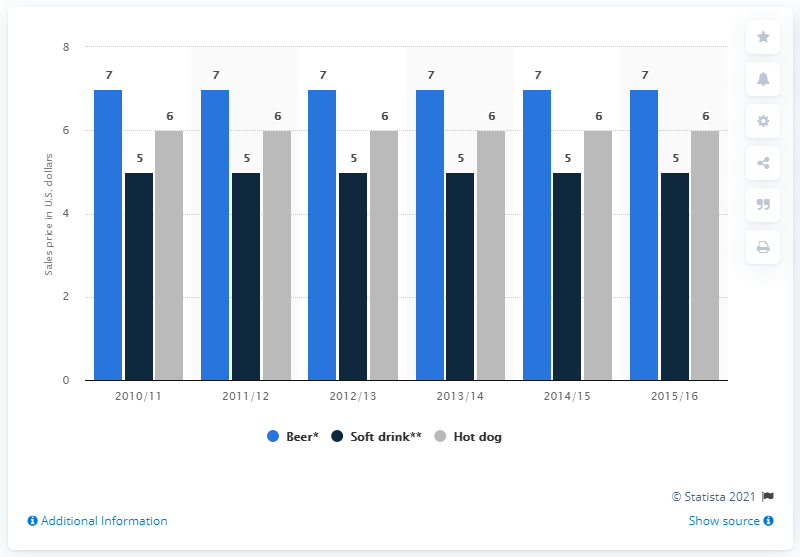Mention a couple of crucial points in this snapshot. The sales price of hot dogs in the year 2015/2016 was approximately $6 in United States dollars. The maximum price of beer is not the same as the minimum price of a hot dog, as the former may vary depending on the location, quality, and other factors, while the latter has a fixed price that is typically lower. 